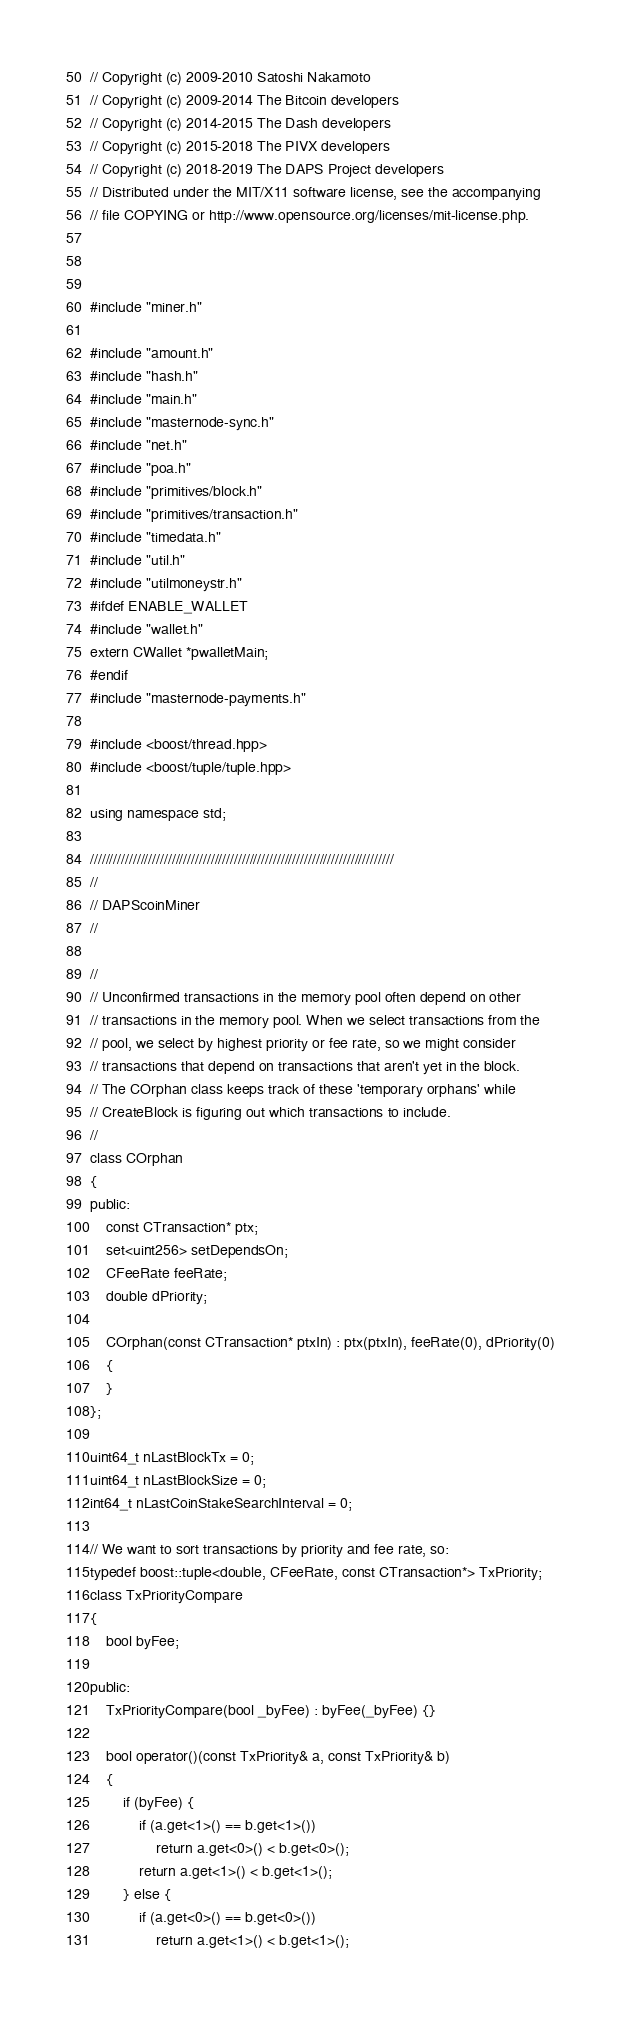<code> <loc_0><loc_0><loc_500><loc_500><_C++_>// Copyright (c) 2009-2010 Satoshi Nakamoto
// Copyright (c) 2009-2014 The Bitcoin developers
// Copyright (c) 2014-2015 The Dash developers
// Copyright (c) 2015-2018 The PIVX developers
// Copyright (c) 2018-2019 The DAPS Project developers
// Distributed under the MIT/X11 software license, see the accompanying
// file COPYING or http://www.opensource.org/licenses/mit-license.php.



#include "miner.h"

#include "amount.h"
#include "hash.h"
#include "main.h"
#include "masternode-sync.h"
#include "net.h"
#include "poa.h"
#include "primitives/block.h"
#include "primitives/transaction.h"
#include "timedata.h"
#include "util.h"
#include "utilmoneystr.h"
#ifdef ENABLE_WALLET
#include "wallet.h"
extern CWallet *pwalletMain;
#endif
#include "masternode-payments.h"

#include <boost/thread.hpp>
#include <boost/tuple/tuple.hpp>

using namespace std;

//////////////////////////////////////////////////////////////////////////////
//
// DAPScoinMiner
//

//
// Unconfirmed transactions in the memory pool often depend on other
// transactions in the memory pool. When we select transactions from the
// pool, we select by highest priority or fee rate, so we might consider
// transactions that depend on transactions that aren't yet in the block.
// The COrphan class keeps track of these 'temporary orphans' while
// CreateBlock is figuring out which transactions to include.
//
class COrphan
{
public:
    const CTransaction* ptx;
    set<uint256> setDependsOn;
    CFeeRate feeRate;
    double dPriority;

    COrphan(const CTransaction* ptxIn) : ptx(ptxIn), feeRate(0), dPriority(0)
    {
    }
};

uint64_t nLastBlockTx = 0;
uint64_t nLastBlockSize = 0;
int64_t nLastCoinStakeSearchInterval = 0;

// We want to sort transactions by priority and fee rate, so:
typedef boost::tuple<double, CFeeRate, const CTransaction*> TxPriority;
class TxPriorityCompare
{
    bool byFee;

public:
    TxPriorityCompare(bool _byFee) : byFee(_byFee) {}

    bool operator()(const TxPriority& a, const TxPriority& b)
    {
        if (byFee) {
            if (a.get<1>() == b.get<1>())
                return a.get<0>() < b.get<0>();
            return a.get<1>() < b.get<1>();
        } else {
            if (a.get<0>() == b.get<0>())
                return a.get<1>() < b.get<1>();</code> 